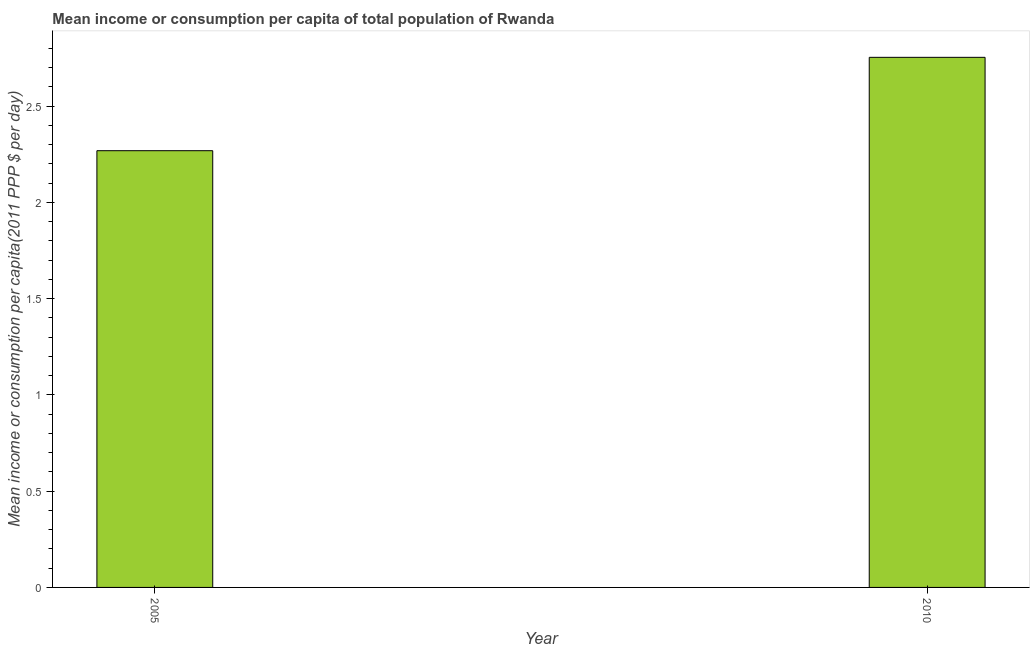Does the graph contain any zero values?
Offer a very short reply. No. What is the title of the graph?
Give a very brief answer. Mean income or consumption per capita of total population of Rwanda. What is the label or title of the Y-axis?
Your answer should be very brief. Mean income or consumption per capita(2011 PPP $ per day). What is the mean income or consumption in 2010?
Provide a short and direct response. 2.75. Across all years, what is the maximum mean income or consumption?
Your answer should be very brief. 2.75. Across all years, what is the minimum mean income or consumption?
Offer a very short reply. 2.27. What is the sum of the mean income or consumption?
Keep it short and to the point. 5.02. What is the difference between the mean income or consumption in 2005 and 2010?
Offer a terse response. -0.48. What is the average mean income or consumption per year?
Make the answer very short. 2.51. What is the median mean income or consumption?
Give a very brief answer. 2.51. Do a majority of the years between 2010 and 2005 (inclusive) have mean income or consumption greater than 2.3 $?
Ensure brevity in your answer.  No. What is the ratio of the mean income or consumption in 2005 to that in 2010?
Ensure brevity in your answer.  0.82. Is the mean income or consumption in 2005 less than that in 2010?
Keep it short and to the point. Yes. In how many years, is the mean income or consumption greater than the average mean income or consumption taken over all years?
Give a very brief answer. 1. Are all the bars in the graph horizontal?
Give a very brief answer. No. Are the values on the major ticks of Y-axis written in scientific E-notation?
Provide a short and direct response. No. What is the Mean income or consumption per capita(2011 PPP $ per day) in 2005?
Offer a very short reply. 2.27. What is the Mean income or consumption per capita(2011 PPP $ per day) of 2010?
Offer a very short reply. 2.75. What is the difference between the Mean income or consumption per capita(2011 PPP $ per day) in 2005 and 2010?
Your answer should be compact. -0.48. What is the ratio of the Mean income or consumption per capita(2011 PPP $ per day) in 2005 to that in 2010?
Make the answer very short. 0.82. 